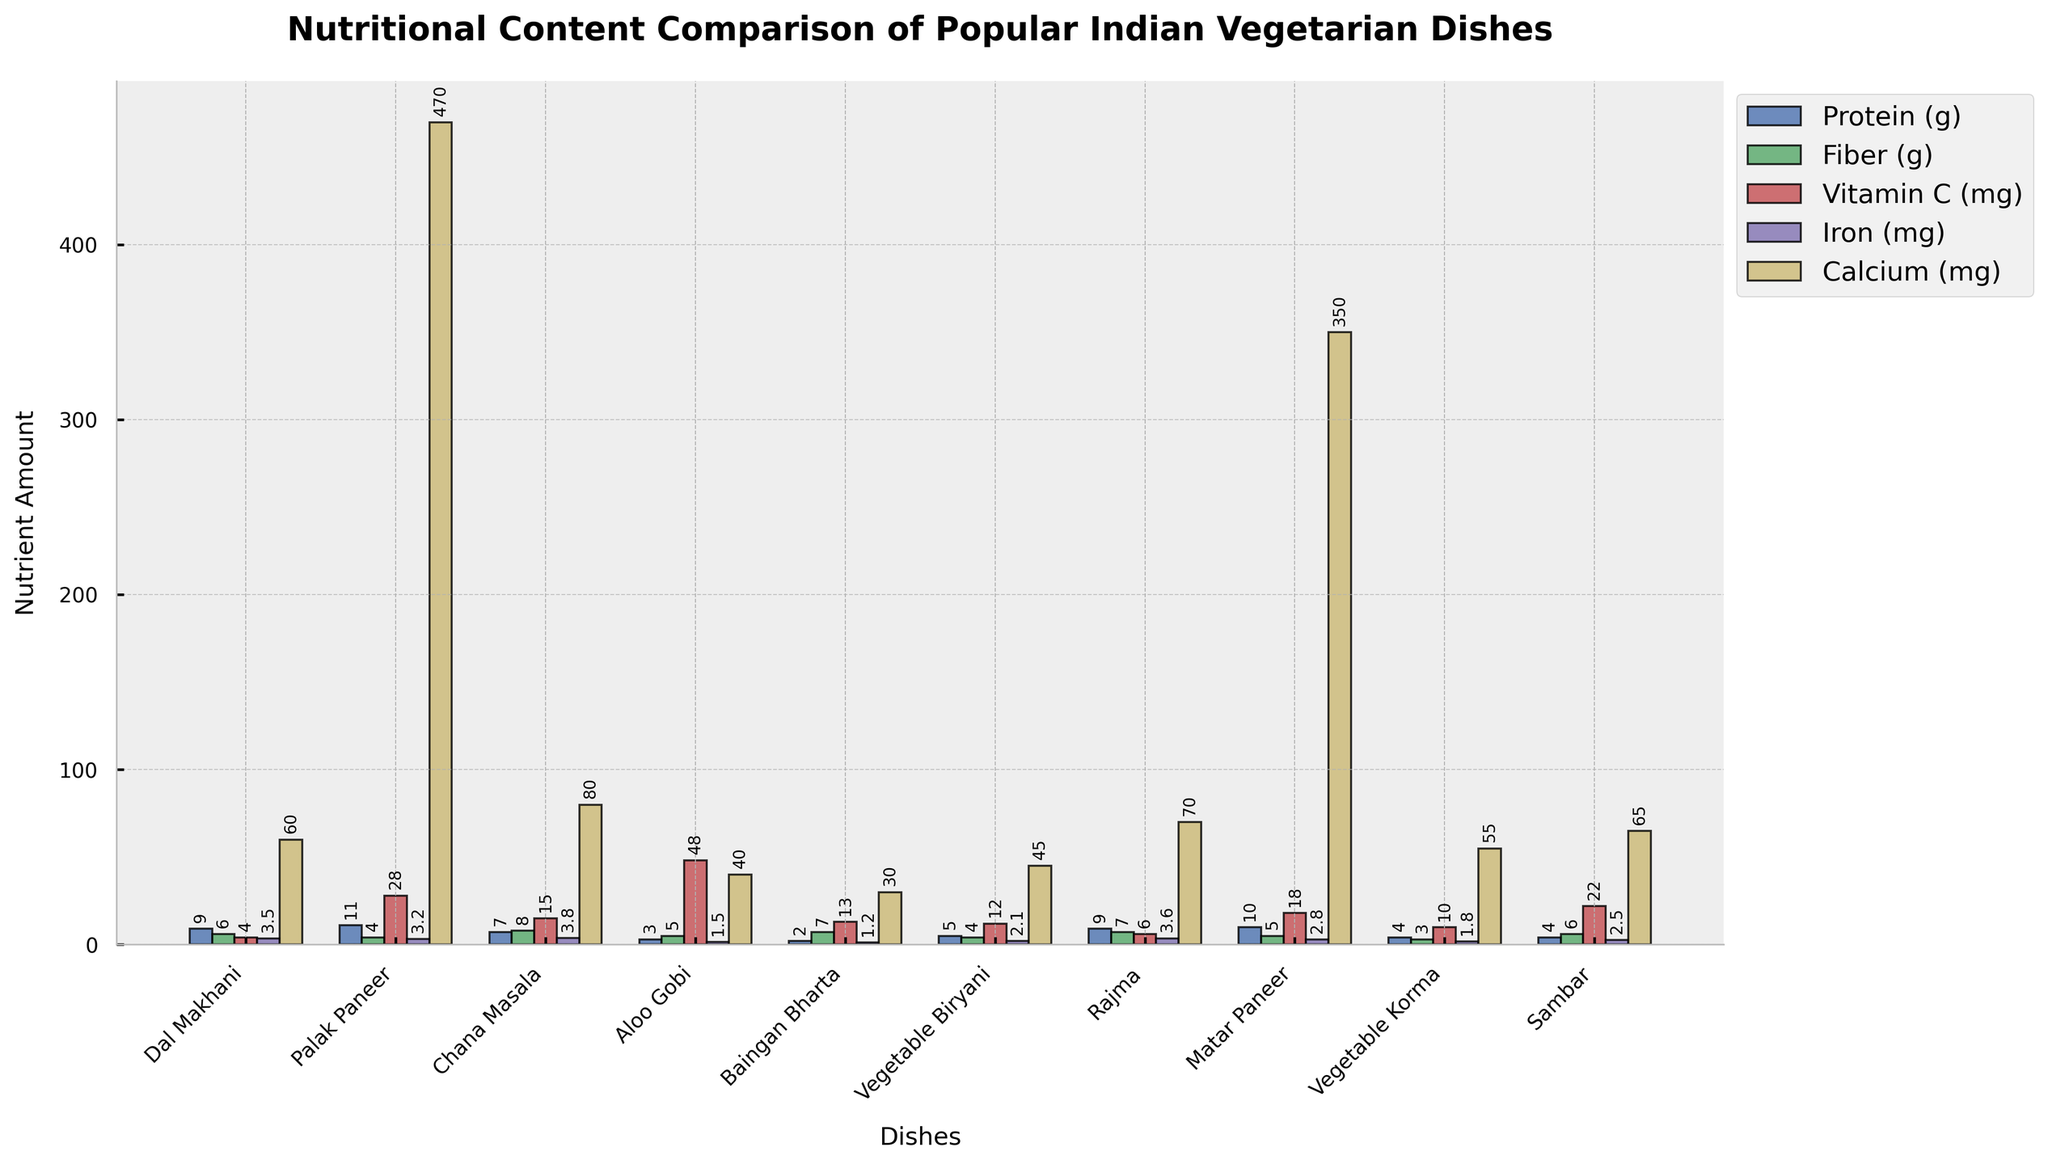Which dish has the highest amount of calcium? From the bar chart, observe the calcium bars for each dish. The highest bar corresponds to "Palak Paneer".
Answer: Palak Paneer Which dish has more iron, Dal Makhani or Rajma? Compare the iron bars for Dal Makhani and Rajma. The bar for Rajma is slightly higher.
Answer: Rajma What is the total amount of protein in Baingan Bharta and Matar Paneer? Add the protein amounts from Baingan Bharta (2 g) and Matar Paneer (10 g). 2 + 10 = 12 grams
Answer: 12 grams Which dish contains the most Vitamin C? Examine the Vitamin C bars for each dish. The highest bar corresponds to Aloo Gobi.
Answer: Aloo Gobi How much more fiber does Chana Masala have compared to Vegetable Biryani? Find the fiber amounts for Chana Masala (8 g) and Vegetable Biryani (4 g). Subtract to find the difference: 8 - 4 = 4 grams
Answer: 4 grams Which dish has the lowest amount of protein? Locate the lowest protein bar, which is for Baingan Bharta at 2 grams.
Answer: Baingan Bharta Between Vegetable Korma and Sambar, which has higher fiber content? Check the fiber bars for Vegetable Korma and Sambar. Sambar has a higher fiber content.
Answer: Sambar What is the average amount of iron in Dal Makhani, Palak Paneer, and Matar Paneer? Add the iron amounts for Dal Makhani (3.5 mg), Palak Paneer (3.2 mg), and Matar Paneer (2.8 mg). Sum: 3.5 + 3.2 + 2.8 = 9.5 mg. Average: 9.5 / 3 = 3.17 mg
Answer: 3.17 mg Which dish has more Vitamin C, Rajma or Sambar? Compare the Vitamin C bars for Rajma (6 mg) and Sambar (22 mg). Sambar has more Vitamin C.
Answer: Sambar How much calcium does Aloo Gobi have compared to Vegetable Biryani? Look at the calcium bars for Aloo Gobi (40 mg) and Vegetable Biryani (45 mg). Vegetable Biryani has 5 mg more calcium.
Answer: 5 mg 